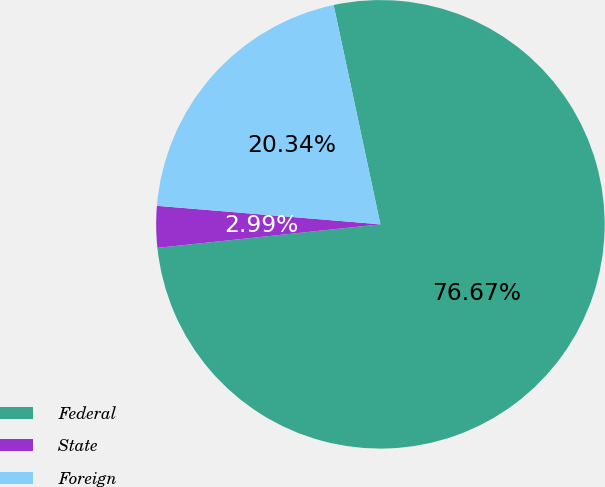Convert chart to OTSL. <chart><loc_0><loc_0><loc_500><loc_500><pie_chart><fcel>Federal<fcel>State<fcel>Foreign<nl><fcel>76.67%<fcel>2.99%<fcel>20.34%<nl></chart> 